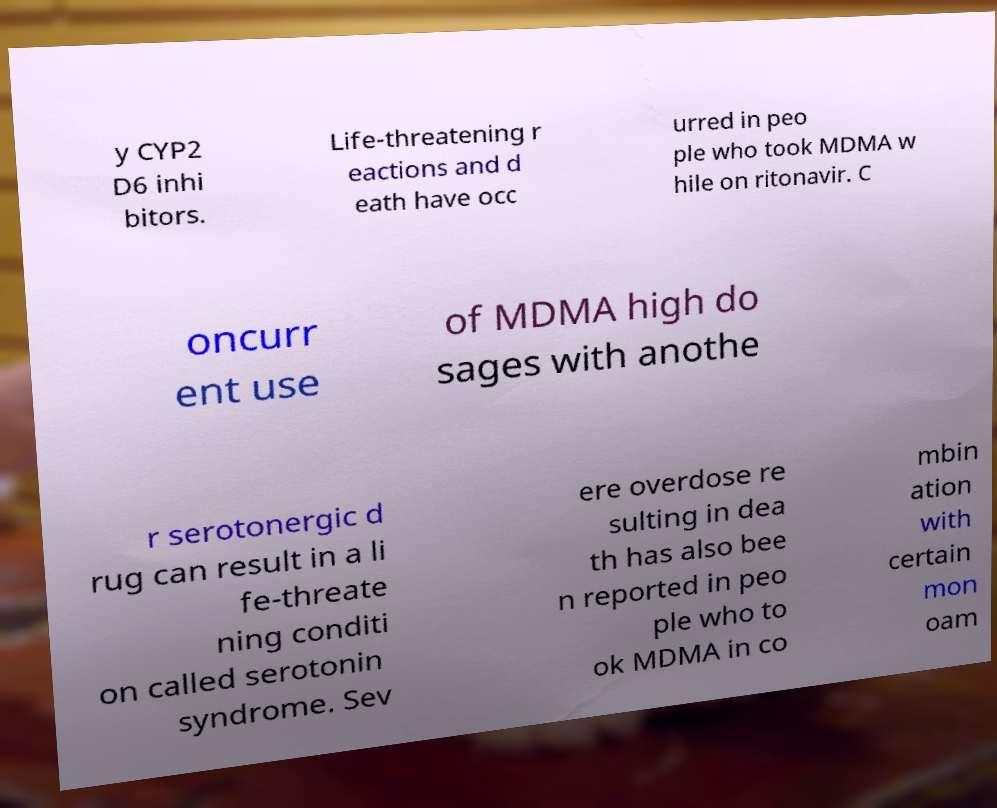For documentation purposes, I need the text within this image transcribed. Could you provide that? y CYP2 D6 inhi bitors. Life-threatening r eactions and d eath have occ urred in peo ple who took MDMA w hile on ritonavir. C oncurr ent use of MDMA high do sages with anothe r serotonergic d rug can result in a li fe-threate ning conditi on called serotonin syndrome. Sev ere overdose re sulting in dea th has also bee n reported in peo ple who to ok MDMA in co mbin ation with certain mon oam 